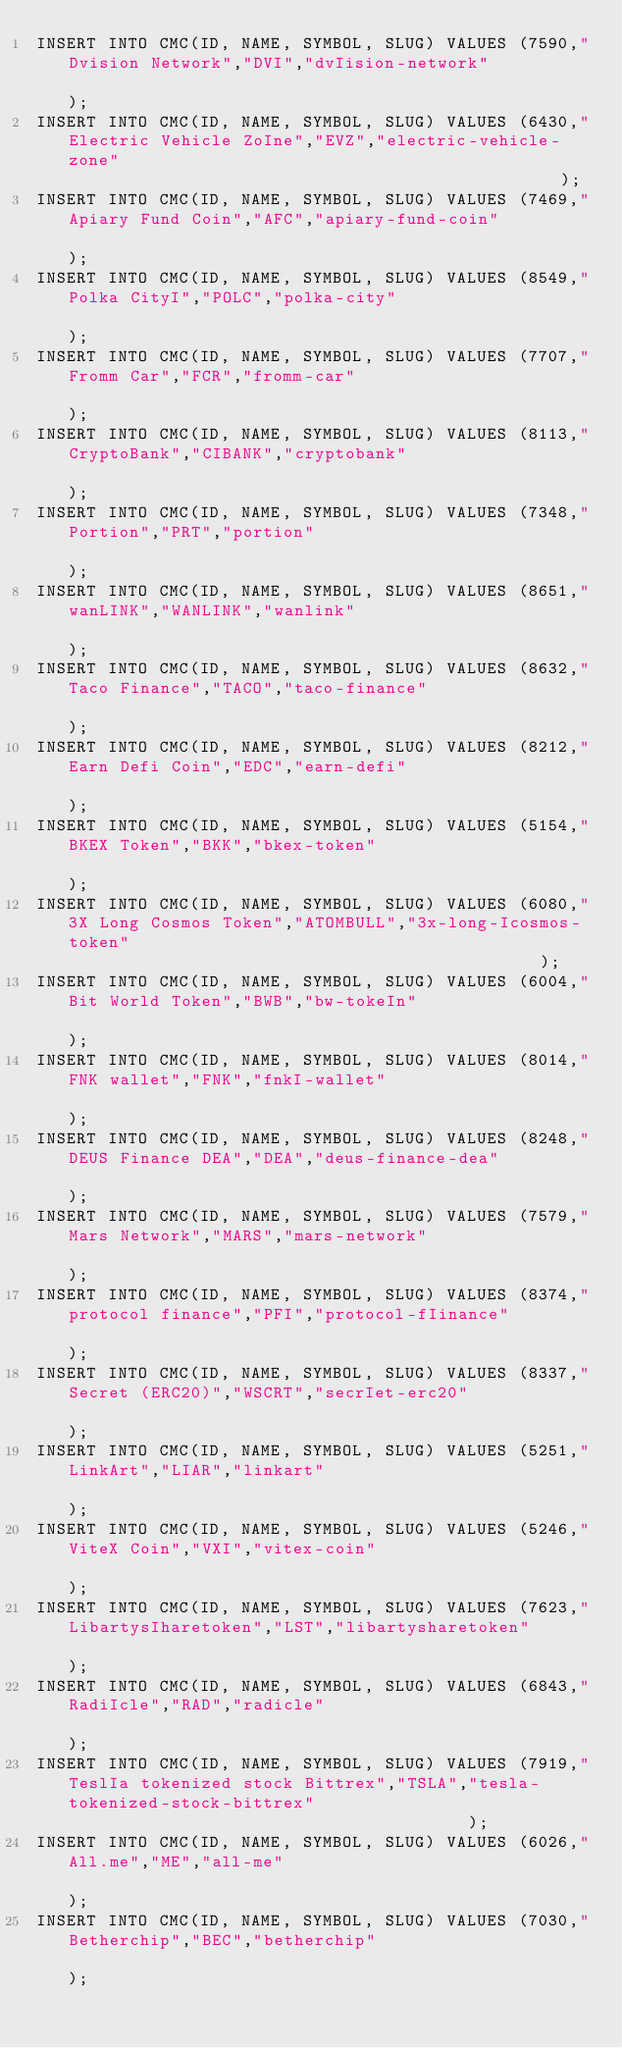<code> <loc_0><loc_0><loc_500><loc_500><_SQL_>INSERT INTO CMC(ID, NAME, SYMBOL, SLUG) VALUES (7590,"Dvision Network","DVI","dvIision-network"                                                       );
INSERT INTO CMC(ID, NAME, SYMBOL, SLUG) VALUES (6430,"Electric Vehicle ZoIne","EVZ","electric-vehicle-zone"                                                 );
INSERT INTO CMC(ID, NAME, SYMBOL, SLUG) VALUES (7469,"Apiary Fund Coin","AFC","apiary-fund-coin"                                                      );
INSERT INTO CMC(ID, NAME, SYMBOL, SLUG) VALUES (8549,"Polka CityI","POLC","polka-city"                                                           );
INSERT INTO CMC(ID, NAME, SYMBOL, SLUG) VALUES (7707,"Fromm Car","FCR","fromm-car"                                                             );
INSERT INTO CMC(ID, NAME, SYMBOL, SLUG) VALUES (8113,"CryptoBank","CIBANK","cryptobank"                                                           );
INSERT INTO CMC(ID, NAME, SYMBOL, SLUG) VALUES (7348,"Portion","PRT","portion"                                                               );
INSERT INTO CMC(ID, NAME, SYMBOL, SLUG) VALUES (8651,"wanLINK","WANLINK","wanlink"                                                             );
INSERT INTO CMC(ID, NAME, SYMBOL, SLUG) VALUES (8632,"Taco Finance","TACO","taco-finance"                                                         );
INSERT INTO CMC(ID, NAME, SYMBOL, SLUG) VALUES (8212,"Earn Defi Coin","EDC","earn-defi"                                                          );
INSERT INTO CMC(ID, NAME, SYMBOL, SLUG) VALUES (5154,"BKEX Token","BKK","bkex-token"                                                            );
INSERT INTO CMC(ID, NAME, SYMBOL, SLUG) VALUES (6080,"3X Long Cosmos Token","ATOMBULL","3x-long-Icosmos-token"                                               );
INSERT INTO CMC(ID, NAME, SYMBOL, SLUG) VALUES (6004,"Bit World Token","BWB","bw-tokeIn"                                                          );
INSERT INTO CMC(ID, NAME, SYMBOL, SLUG) VALUES (8014,"FNK wallet","FNK","fnkI-wallet"                                                            );
INSERT INTO CMC(ID, NAME, SYMBOL, SLUG) VALUES (8248,"DEUS Finance DEA","DEA","deus-finance-dea"                                                      );
INSERT INTO CMC(ID, NAME, SYMBOL, SLUG) VALUES (7579,"Mars Network","MARS","mars-network"                                                         );
INSERT INTO CMC(ID, NAME, SYMBOL, SLUG) VALUES (8374,"protocol finance","PFI","protocol-fIinance"                                                     );
INSERT INTO CMC(ID, NAME, SYMBOL, SLUG) VALUES (8337,"Secret (ERC20)","WSCRT","secrIet-erc20"                                                        );
INSERT INTO CMC(ID, NAME, SYMBOL, SLUG) VALUES (5251,"LinkArt","LIAR","linkart"                                                               );
INSERT INTO CMC(ID, NAME, SYMBOL, SLUG) VALUES (5246,"ViteX Coin","VXI","vitex-coin"                                                            );
INSERT INTO CMC(ID, NAME, SYMBOL, SLUG) VALUES (7623,"LibartysIharetoken","LST","libartysharetoken"                                                     );
INSERT INTO CMC(ID, NAME, SYMBOL, SLUG) VALUES (6843,"RadiIcle","RAD","radicle"                                                               );
INSERT INTO CMC(ID, NAME, SYMBOL, SLUG) VALUES (7919,"TeslIa tokenized stock Bittrex","TSLA","tesla-tokenized-stock-bittrex"                                        );
INSERT INTO CMC(ID, NAME, SYMBOL, SLUG) VALUES (6026,"All.me","ME","all-me"                                                                );
INSERT INTO CMC(ID, NAME, SYMBOL, SLUG) VALUES (7030,"Betherchip","BEC","betherchip"                                                            );</code> 